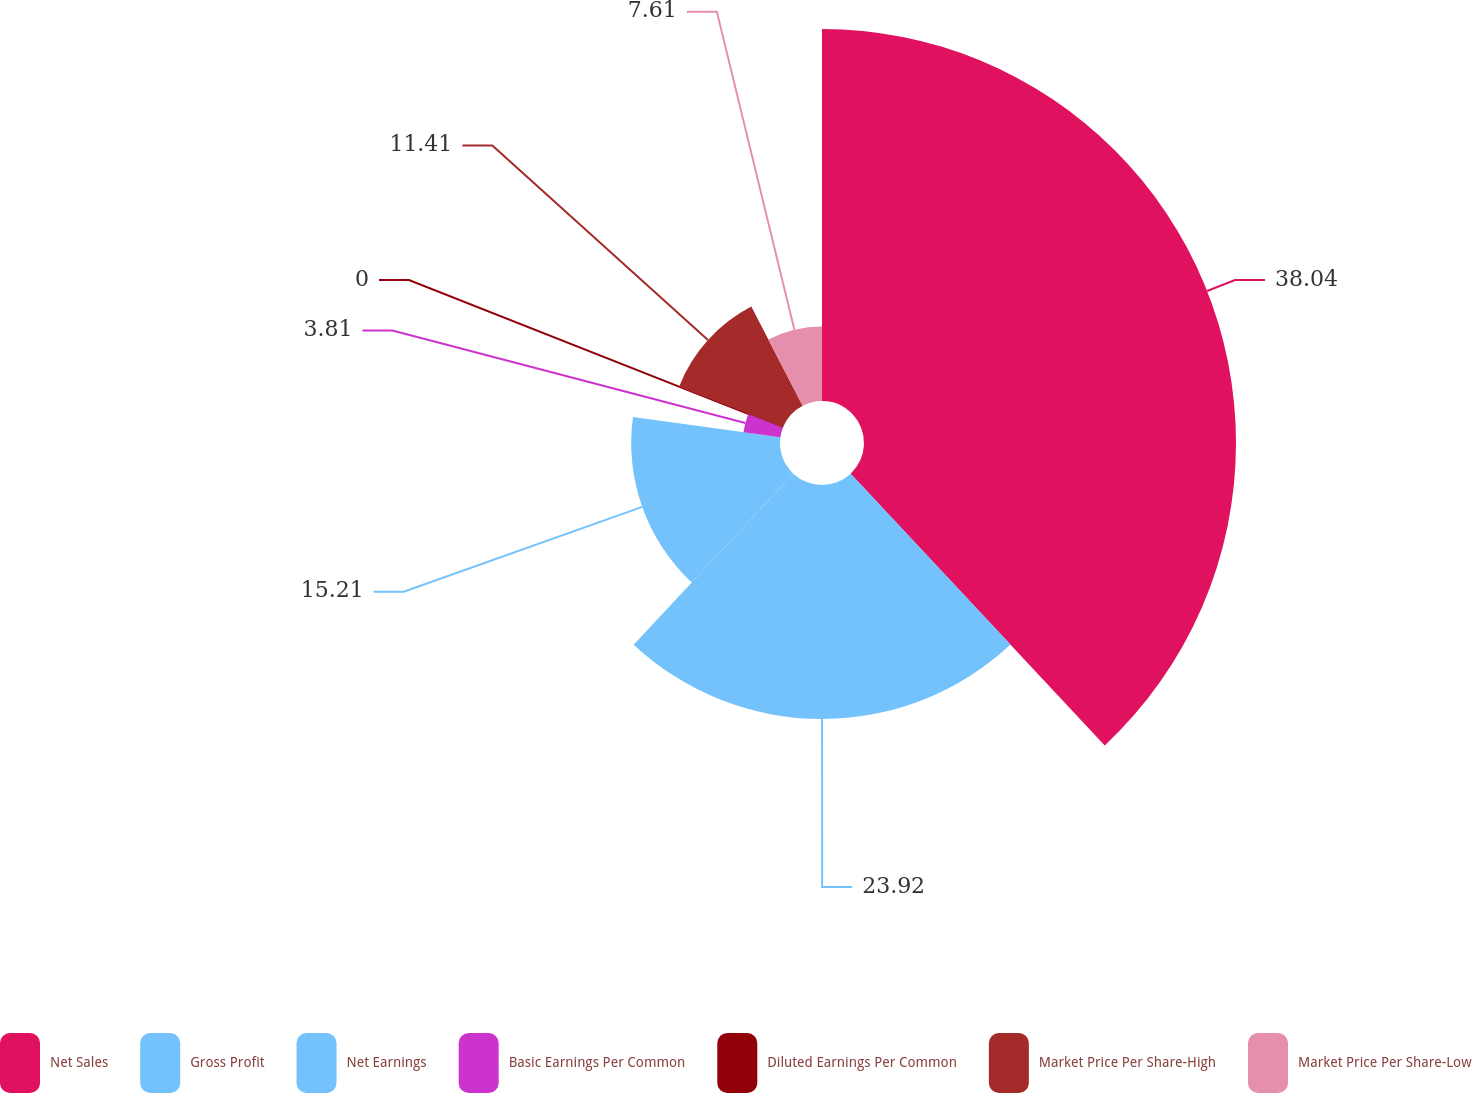Convert chart. <chart><loc_0><loc_0><loc_500><loc_500><pie_chart><fcel>Net Sales<fcel>Gross Profit<fcel>Net Earnings<fcel>Basic Earnings Per Common<fcel>Diluted Earnings Per Common<fcel>Market Price Per Share-High<fcel>Market Price Per Share-Low<nl><fcel>38.03%<fcel>23.92%<fcel>15.21%<fcel>3.81%<fcel>0.0%<fcel>11.41%<fcel>7.61%<nl></chart> 